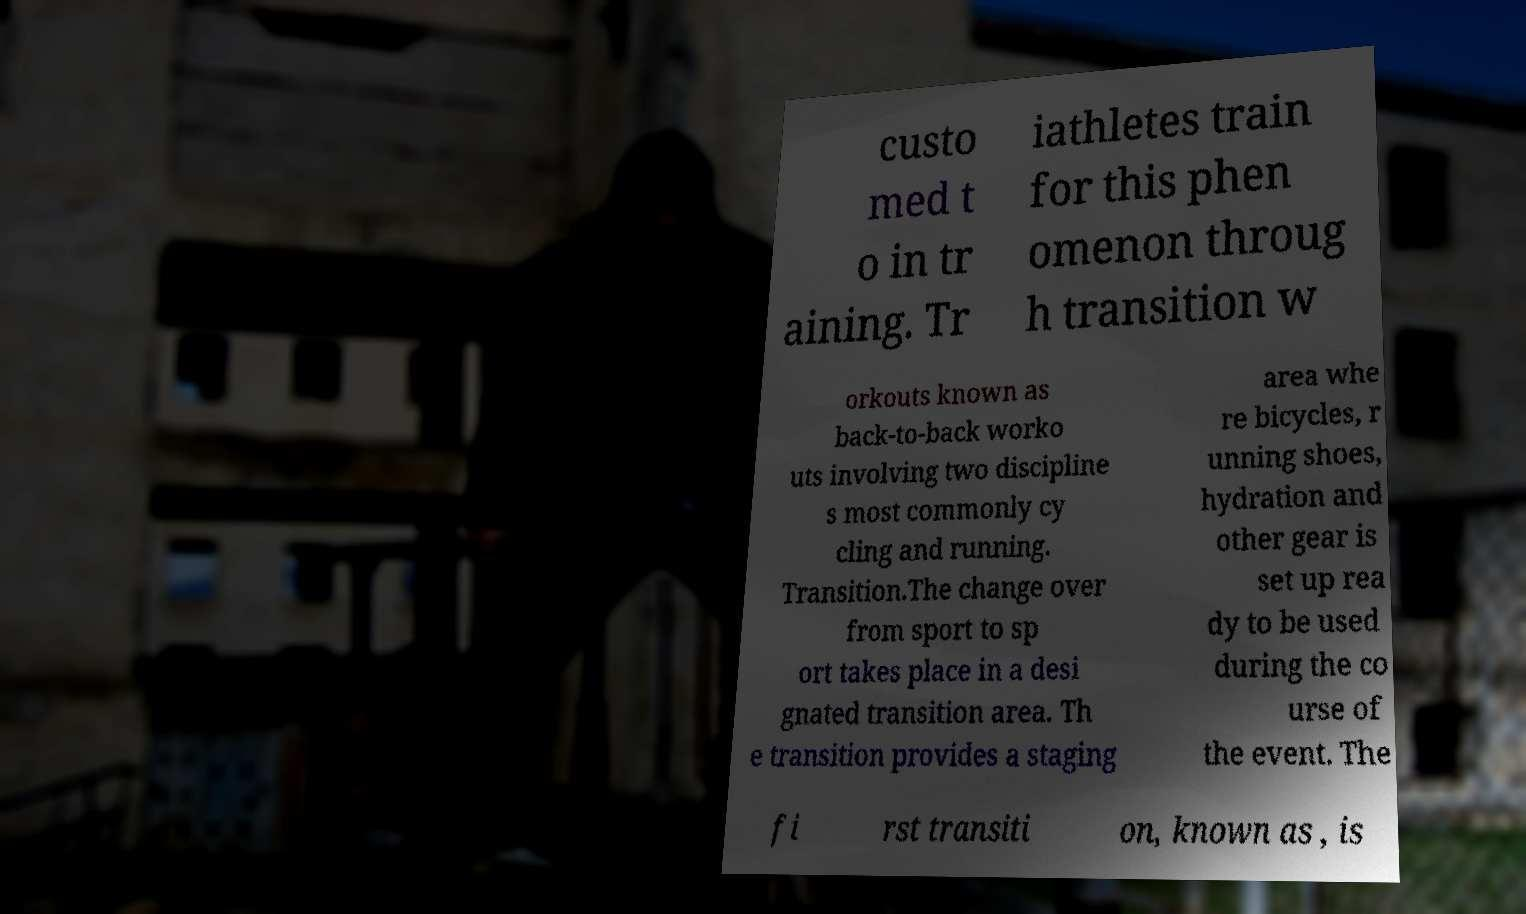Please read and relay the text visible in this image. What does it say? custo med t o in tr aining. Tr iathletes train for this phen omenon throug h transition w orkouts known as back-to-back worko uts involving two discipline s most commonly cy cling and running. Transition.The change over from sport to sp ort takes place in a desi gnated transition area. Th e transition provides a staging area whe re bicycles, r unning shoes, hydration and other gear is set up rea dy to be used during the co urse of the event. The fi rst transiti on, known as , is 